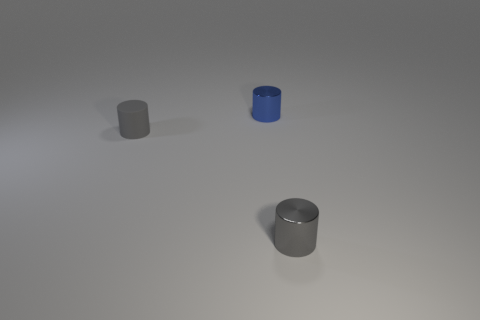Add 3 tiny blue cylinders. How many objects exist? 6 Add 2 gray cylinders. How many gray cylinders are left? 4 Add 2 gray rubber cylinders. How many gray rubber cylinders exist? 3 Subtract 0 cyan blocks. How many objects are left? 3 Subtract all small blue cylinders. Subtract all gray metallic spheres. How many objects are left? 2 